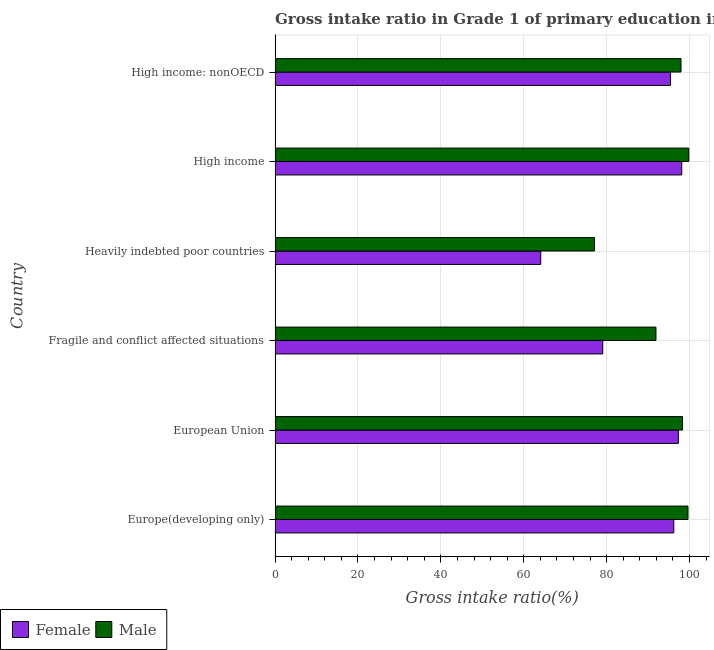How many different coloured bars are there?
Give a very brief answer. 2. Are the number of bars on each tick of the Y-axis equal?
Offer a very short reply. Yes. How many bars are there on the 4th tick from the top?
Provide a short and direct response. 2. What is the label of the 1st group of bars from the top?
Provide a succinct answer. High income: nonOECD. In how many cases, is the number of bars for a given country not equal to the number of legend labels?
Keep it short and to the point. 0. What is the gross intake ratio(female) in Heavily indebted poor countries?
Provide a succinct answer. 64.11. Across all countries, what is the maximum gross intake ratio(female)?
Keep it short and to the point. 98.13. Across all countries, what is the minimum gross intake ratio(male)?
Provide a short and direct response. 77.06. In which country was the gross intake ratio(female) maximum?
Your response must be concise. High income. In which country was the gross intake ratio(female) minimum?
Provide a short and direct response. Heavily indebted poor countries. What is the total gross intake ratio(female) in the graph?
Your answer should be very brief. 530.27. What is the difference between the gross intake ratio(female) in Europe(developing only) and that in High income: nonOECD?
Provide a short and direct response. 0.78. What is the difference between the gross intake ratio(male) in High income: nonOECD and the gross intake ratio(female) in European Union?
Your answer should be compact. 0.64. What is the average gross intake ratio(male) per country?
Offer a terse response. 94.12. What is the difference between the gross intake ratio(female) and gross intake ratio(male) in High income: nonOECD?
Your answer should be compact. -2.53. What is the ratio of the gross intake ratio(male) in High income to that in High income: nonOECD?
Make the answer very short. 1.02. What is the difference between the highest and the second highest gross intake ratio(male)?
Give a very brief answer. 0.2. What is the difference between the highest and the lowest gross intake ratio(female)?
Provide a short and direct response. 34.03. In how many countries, is the gross intake ratio(female) greater than the average gross intake ratio(female) taken over all countries?
Provide a short and direct response. 4. What does the 1st bar from the bottom in Europe(developing only) represents?
Offer a terse response. Female. How many bars are there?
Provide a succinct answer. 12. Are all the bars in the graph horizontal?
Provide a short and direct response. Yes. Are the values on the major ticks of X-axis written in scientific E-notation?
Keep it short and to the point. No. Where does the legend appear in the graph?
Offer a very short reply. Bottom left. What is the title of the graph?
Your answer should be compact. Gross intake ratio in Grade 1 of primary education in the year 1992. What is the label or title of the X-axis?
Give a very brief answer. Gross intake ratio(%). What is the Gross intake ratio(%) in Female in Europe(developing only)?
Your answer should be very brief. 96.21. What is the Gross intake ratio(%) in Male in Europe(developing only)?
Your response must be concise. 99.64. What is the Gross intake ratio(%) of Female in European Union?
Offer a terse response. 97.31. What is the Gross intake ratio(%) of Male in European Union?
Offer a very short reply. 98.32. What is the Gross intake ratio(%) of Female in Fragile and conflict affected situations?
Provide a short and direct response. 79.07. What is the Gross intake ratio(%) in Male in Fragile and conflict affected situations?
Ensure brevity in your answer.  91.91. What is the Gross intake ratio(%) of Female in Heavily indebted poor countries?
Give a very brief answer. 64.11. What is the Gross intake ratio(%) in Male in Heavily indebted poor countries?
Make the answer very short. 77.06. What is the Gross intake ratio(%) of Female in High income?
Your answer should be compact. 98.13. What is the Gross intake ratio(%) in Male in High income?
Ensure brevity in your answer.  99.84. What is the Gross intake ratio(%) of Female in High income: nonOECD?
Provide a succinct answer. 95.43. What is the Gross intake ratio(%) of Male in High income: nonOECD?
Make the answer very short. 97.96. Across all countries, what is the maximum Gross intake ratio(%) of Female?
Keep it short and to the point. 98.13. Across all countries, what is the maximum Gross intake ratio(%) in Male?
Offer a very short reply. 99.84. Across all countries, what is the minimum Gross intake ratio(%) in Female?
Offer a very short reply. 64.11. Across all countries, what is the minimum Gross intake ratio(%) in Male?
Give a very brief answer. 77.06. What is the total Gross intake ratio(%) of Female in the graph?
Give a very brief answer. 530.27. What is the total Gross intake ratio(%) in Male in the graph?
Provide a succinct answer. 564.72. What is the difference between the Gross intake ratio(%) of Female in Europe(developing only) and that in European Union?
Ensure brevity in your answer.  -1.1. What is the difference between the Gross intake ratio(%) in Male in Europe(developing only) and that in European Union?
Keep it short and to the point. 1.32. What is the difference between the Gross intake ratio(%) in Female in Europe(developing only) and that in Fragile and conflict affected situations?
Offer a very short reply. 17.15. What is the difference between the Gross intake ratio(%) of Male in Europe(developing only) and that in Fragile and conflict affected situations?
Give a very brief answer. 7.73. What is the difference between the Gross intake ratio(%) in Female in Europe(developing only) and that in Heavily indebted poor countries?
Provide a short and direct response. 32.11. What is the difference between the Gross intake ratio(%) in Male in Europe(developing only) and that in Heavily indebted poor countries?
Make the answer very short. 22.58. What is the difference between the Gross intake ratio(%) in Female in Europe(developing only) and that in High income?
Offer a terse response. -1.92. What is the difference between the Gross intake ratio(%) in Male in Europe(developing only) and that in High income?
Provide a succinct answer. -0.2. What is the difference between the Gross intake ratio(%) in Female in Europe(developing only) and that in High income: nonOECD?
Offer a very short reply. 0.78. What is the difference between the Gross intake ratio(%) of Male in Europe(developing only) and that in High income: nonOECD?
Make the answer very short. 1.68. What is the difference between the Gross intake ratio(%) in Female in European Union and that in Fragile and conflict affected situations?
Your answer should be compact. 18.24. What is the difference between the Gross intake ratio(%) in Male in European Union and that in Fragile and conflict affected situations?
Offer a terse response. 6.41. What is the difference between the Gross intake ratio(%) of Female in European Union and that in Heavily indebted poor countries?
Keep it short and to the point. 33.21. What is the difference between the Gross intake ratio(%) of Male in European Union and that in Heavily indebted poor countries?
Offer a terse response. 21.26. What is the difference between the Gross intake ratio(%) of Female in European Union and that in High income?
Your answer should be very brief. -0.82. What is the difference between the Gross intake ratio(%) in Male in European Union and that in High income?
Offer a terse response. -1.52. What is the difference between the Gross intake ratio(%) in Female in European Union and that in High income: nonOECD?
Keep it short and to the point. 1.88. What is the difference between the Gross intake ratio(%) of Male in European Union and that in High income: nonOECD?
Offer a very short reply. 0.36. What is the difference between the Gross intake ratio(%) in Female in Fragile and conflict affected situations and that in Heavily indebted poor countries?
Provide a short and direct response. 14.96. What is the difference between the Gross intake ratio(%) of Male in Fragile and conflict affected situations and that in Heavily indebted poor countries?
Ensure brevity in your answer.  14.85. What is the difference between the Gross intake ratio(%) of Female in Fragile and conflict affected situations and that in High income?
Ensure brevity in your answer.  -19.06. What is the difference between the Gross intake ratio(%) of Male in Fragile and conflict affected situations and that in High income?
Give a very brief answer. -7.93. What is the difference between the Gross intake ratio(%) in Female in Fragile and conflict affected situations and that in High income: nonOECD?
Offer a very short reply. -16.36. What is the difference between the Gross intake ratio(%) in Male in Fragile and conflict affected situations and that in High income: nonOECD?
Offer a very short reply. -6.05. What is the difference between the Gross intake ratio(%) in Female in Heavily indebted poor countries and that in High income?
Ensure brevity in your answer.  -34.03. What is the difference between the Gross intake ratio(%) of Male in Heavily indebted poor countries and that in High income?
Your response must be concise. -22.77. What is the difference between the Gross intake ratio(%) in Female in Heavily indebted poor countries and that in High income: nonOECD?
Give a very brief answer. -31.32. What is the difference between the Gross intake ratio(%) in Male in Heavily indebted poor countries and that in High income: nonOECD?
Give a very brief answer. -20.9. What is the difference between the Gross intake ratio(%) of Female in High income and that in High income: nonOECD?
Provide a succinct answer. 2.7. What is the difference between the Gross intake ratio(%) of Male in High income and that in High income: nonOECD?
Make the answer very short. 1.88. What is the difference between the Gross intake ratio(%) of Female in Europe(developing only) and the Gross intake ratio(%) of Male in European Union?
Your answer should be very brief. -2.1. What is the difference between the Gross intake ratio(%) in Female in Europe(developing only) and the Gross intake ratio(%) in Male in Fragile and conflict affected situations?
Ensure brevity in your answer.  4.31. What is the difference between the Gross intake ratio(%) of Female in Europe(developing only) and the Gross intake ratio(%) of Male in Heavily indebted poor countries?
Provide a succinct answer. 19.15. What is the difference between the Gross intake ratio(%) in Female in Europe(developing only) and the Gross intake ratio(%) in Male in High income?
Ensure brevity in your answer.  -3.62. What is the difference between the Gross intake ratio(%) in Female in Europe(developing only) and the Gross intake ratio(%) in Male in High income: nonOECD?
Your answer should be very brief. -1.74. What is the difference between the Gross intake ratio(%) in Female in European Union and the Gross intake ratio(%) in Male in Fragile and conflict affected situations?
Your response must be concise. 5.4. What is the difference between the Gross intake ratio(%) in Female in European Union and the Gross intake ratio(%) in Male in Heavily indebted poor countries?
Provide a succinct answer. 20.25. What is the difference between the Gross intake ratio(%) in Female in European Union and the Gross intake ratio(%) in Male in High income?
Give a very brief answer. -2.52. What is the difference between the Gross intake ratio(%) in Female in European Union and the Gross intake ratio(%) in Male in High income: nonOECD?
Make the answer very short. -0.64. What is the difference between the Gross intake ratio(%) in Female in Fragile and conflict affected situations and the Gross intake ratio(%) in Male in Heavily indebted poor countries?
Keep it short and to the point. 2.01. What is the difference between the Gross intake ratio(%) in Female in Fragile and conflict affected situations and the Gross intake ratio(%) in Male in High income?
Give a very brief answer. -20.77. What is the difference between the Gross intake ratio(%) of Female in Fragile and conflict affected situations and the Gross intake ratio(%) of Male in High income: nonOECD?
Offer a very short reply. -18.89. What is the difference between the Gross intake ratio(%) in Female in Heavily indebted poor countries and the Gross intake ratio(%) in Male in High income?
Give a very brief answer. -35.73. What is the difference between the Gross intake ratio(%) in Female in Heavily indebted poor countries and the Gross intake ratio(%) in Male in High income: nonOECD?
Your answer should be very brief. -33.85. What is the difference between the Gross intake ratio(%) in Female in High income and the Gross intake ratio(%) in Male in High income: nonOECD?
Keep it short and to the point. 0.18. What is the average Gross intake ratio(%) of Female per country?
Ensure brevity in your answer.  88.38. What is the average Gross intake ratio(%) of Male per country?
Make the answer very short. 94.12. What is the difference between the Gross intake ratio(%) of Female and Gross intake ratio(%) of Male in Europe(developing only)?
Your answer should be compact. -3.42. What is the difference between the Gross intake ratio(%) of Female and Gross intake ratio(%) of Male in European Union?
Offer a terse response. -1.01. What is the difference between the Gross intake ratio(%) in Female and Gross intake ratio(%) in Male in Fragile and conflict affected situations?
Provide a short and direct response. -12.84. What is the difference between the Gross intake ratio(%) of Female and Gross intake ratio(%) of Male in Heavily indebted poor countries?
Keep it short and to the point. -12.95. What is the difference between the Gross intake ratio(%) in Female and Gross intake ratio(%) in Male in High income?
Make the answer very short. -1.7. What is the difference between the Gross intake ratio(%) of Female and Gross intake ratio(%) of Male in High income: nonOECD?
Ensure brevity in your answer.  -2.53. What is the ratio of the Gross intake ratio(%) of Female in Europe(developing only) to that in European Union?
Provide a short and direct response. 0.99. What is the ratio of the Gross intake ratio(%) in Male in Europe(developing only) to that in European Union?
Provide a short and direct response. 1.01. What is the ratio of the Gross intake ratio(%) of Female in Europe(developing only) to that in Fragile and conflict affected situations?
Ensure brevity in your answer.  1.22. What is the ratio of the Gross intake ratio(%) in Male in Europe(developing only) to that in Fragile and conflict affected situations?
Your response must be concise. 1.08. What is the ratio of the Gross intake ratio(%) in Female in Europe(developing only) to that in Heavily indebted poor countries?
Your response must be concise. 1.5. What is the ratio of the Gross intake ratio(%) of Male in Europe(developing only) to that in Heavily indebted poor countries?
Your answer should be very brief. 1.29. What is the ratio of the Gross intake ratio(%) of Female in Europe(developing only) to that in High income?
Your answer should be compact. 0.98. What is the ratio of the Gross intake ratio(%) in Female in Europe(developing only) to that in High income: nonOECD?
Your response must be concise. 1.01. What is the ratio of the Gross intake ratio(%) of Male in Europe(developing only) to that in High income: nonOECD?
Offer a very short reply. 1.02. What is the ratio of the Gross intake ratio(%) in Female in European Union to that in Fragile and conflict affected situations?
Offer a terse response. 1.23. What is the ratio of the Gross intake ratio(%) in Male in European Union to that in Fragile and conflict affected situations?
Offer a terse response. 1.07. What is the ratio of the Gross intake ratio(%) of Female in European Union to that in Heavily indebted poor countries?
Ensure brevity in your answer.  1.52. What is the ratio of the Gross intake ratio(%) in Male in European Union to that in Heavily indebted poor countries?
Offer a terse response. 1.28. What is the ratio of the Gross intake ratio(%) of Male in European Union to that in High income?
Offer a terse response. 0.98. What is the ratio of the Gross intake ratio(%) in Female in European Union to that in High income: nonOECD?
Your response must be concise. 1.02. What is the ratio of the Gross intake ratio(%) of Male in European Union to that in High income: nonOECD?
Provide a short and direct response. 1. What is the ratio of the Gross intake ratio(%) of Female in Fragile and conflict affected situations to that in Heavily indebted poor countries?
Make the answer very short. 1.23. What is the ratio of the Gross intake ratio(%) of Male in Fragile and conflict affected situations to that in Heavily indebted poor countries?
Your response must be concise. 1.19. What is the ratio of the Gross intake ratio(%) of Female in Fragile and conflict affected situations to that in High income?
Your answer should be compact. 0.81. What is the ratio of the Gross intake ratio(%) in Male in Fragile and conflict affected situations to that in High income?
Make the answer very short. 0.92. What is the ratio of the Gross intake ratio(%) in Female in Fragile and conflict affected situations to that in High income: nonOECD?
Make the answer very short. 0.83. What is the ratio of the Gross intake ratio(%) of Male in Fragile and conflict affected situations to that in High income: nonOECD?
Give a very brief answer. 0.94. What is the ratio of the Gross intake ratio(%) in Female in Heavily indebted poor countries to that in High income?
Your answer should be compact. 0.65. What is the ratio of the Gross intake ratio(%) of Male in Heavily indebted poor countries to that in High income?
Provide a short and direct response. 0.77. What is the ratio of the Gross intake ratio(%) of Female in Heavily indebted poor countries to that in High income: nonOECD?
Keep it short and to the point. 0.67. What is the ratio of the Gross intake ratio(%) in Male in Heavily indebted poor countries to that in High income: nonOECD?
Give a very brief answer. 0.79. What is the ratio of the Gross intake ratio(%) in Female in High income to that in High income: nonOECD?
Offer a very short reply. 1.03. What is the ratio of the Gross intake ratio(%) in Male in High income to that in High income: nonOECD?
Keep it short and to the point. 1.02. What is the difference between the highest and the second highest Gross intake ratio(%) of Female?
Your answer should be compact. 0.82. What is the difference between the highest and the second highest Gross intake ratio(%) of Male?
Provide a short and direct response. 0.2. What is the difference between the highest and the lowest Gross intake ratio(%) in Female?
Your answer should be compact. 34.03. What is the difference between the highest and the lowest Gross intake ratio(%) in Male?
Make the answer very short. 22.77. 